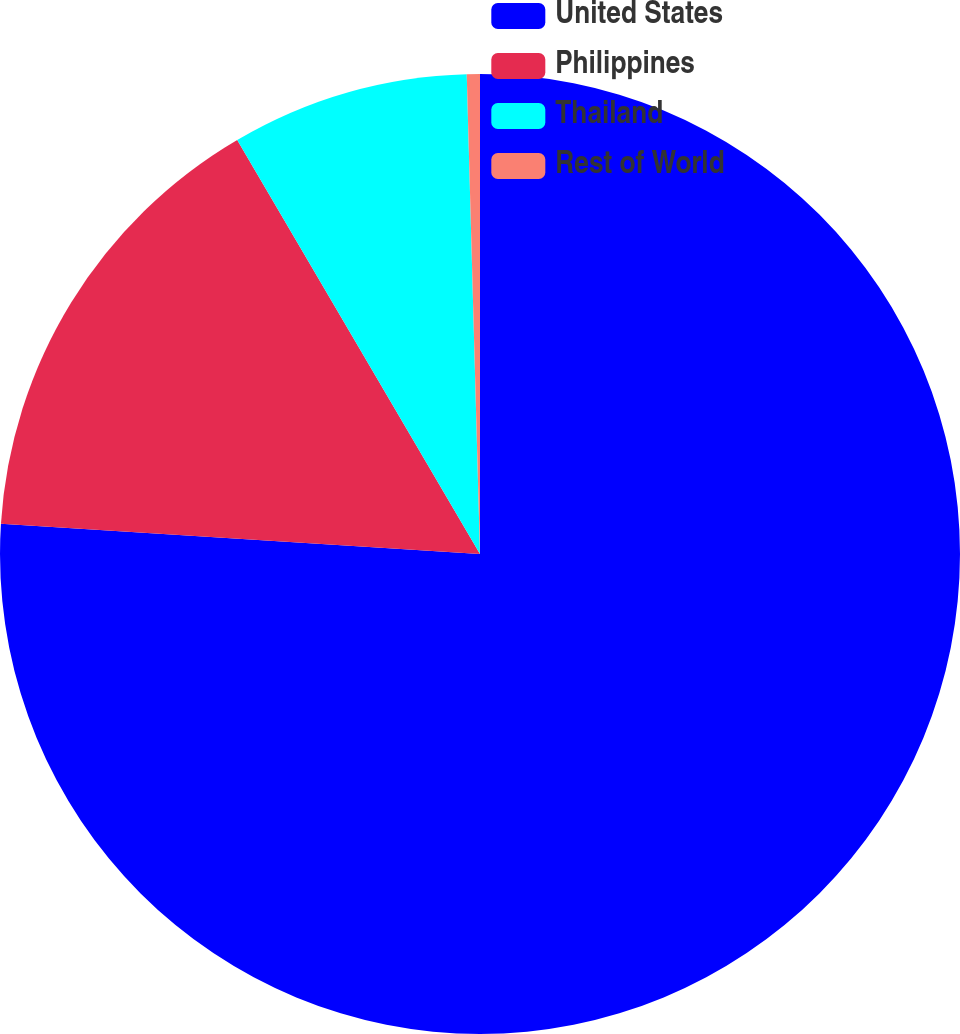Convert chart to OTSL. <chart><loc_0><loc_0><loc_500><loc_500><pie_chart><fcel>United States<fcel>Philippines<fcel>Thailand<fcel>Rest of World<nl><fcel>76.0%<fcel>15.56%<fcel>8.0%<fcel>0.44%<nl></chart> 